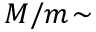<formula> <loc_0><loc_0><loc_500><loc_500>M / m \, \sim</formula> 